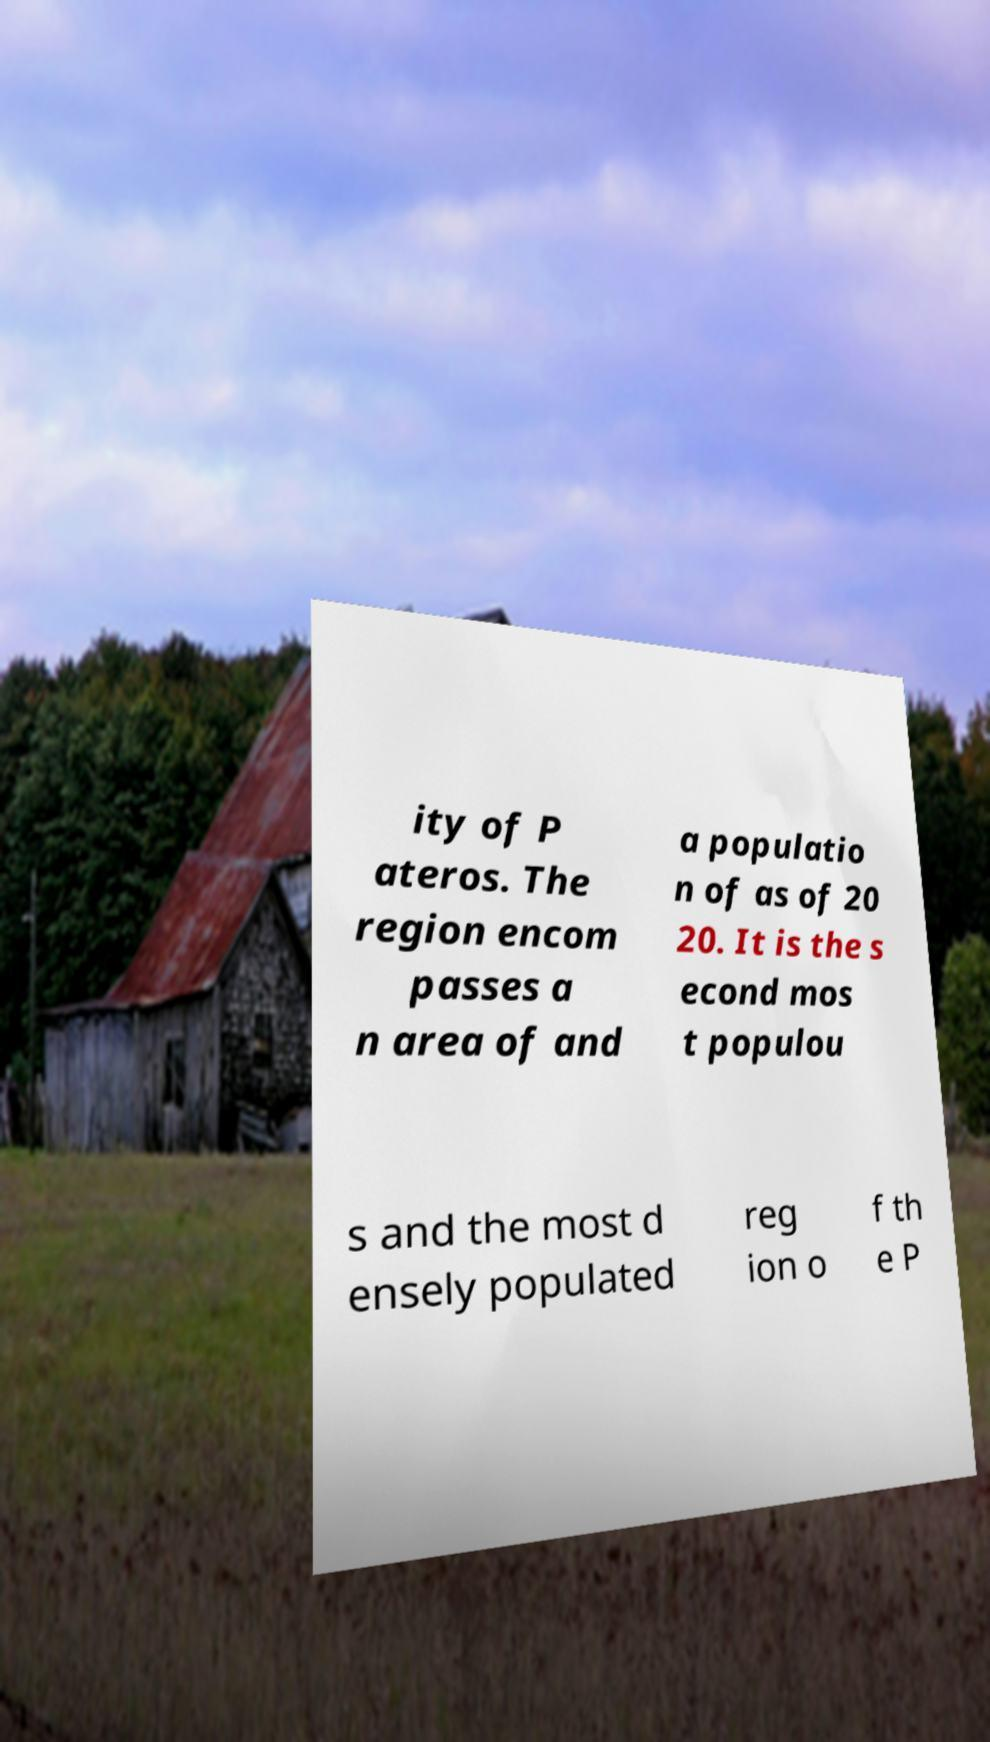Please read and relay the text visible in this image. What does it say? ity of P ateros. The region encom passes a n area of and a populatio n of as of 20 20. It is the s econd mos t populou s and the most d ensely populated reg ion o f th e P 